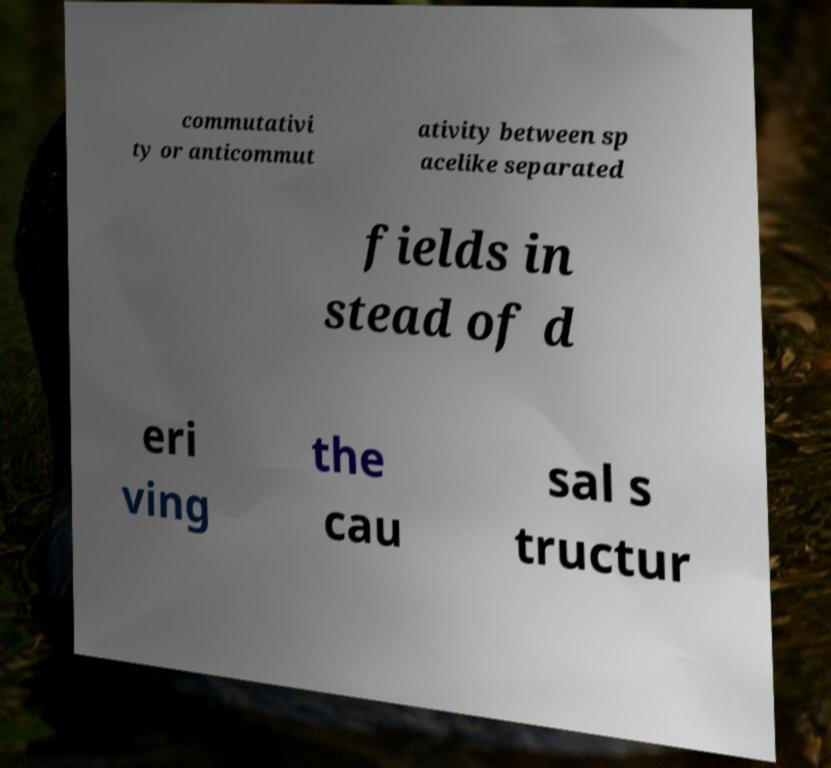Can you read and provide the text displayed in the image?This photo seems to have some interesting text. Can you extract and type it out for me? commutativi ty or anticommut ativity between sp acelike separated fields in stead of d eri ving the cau sal s tructur 